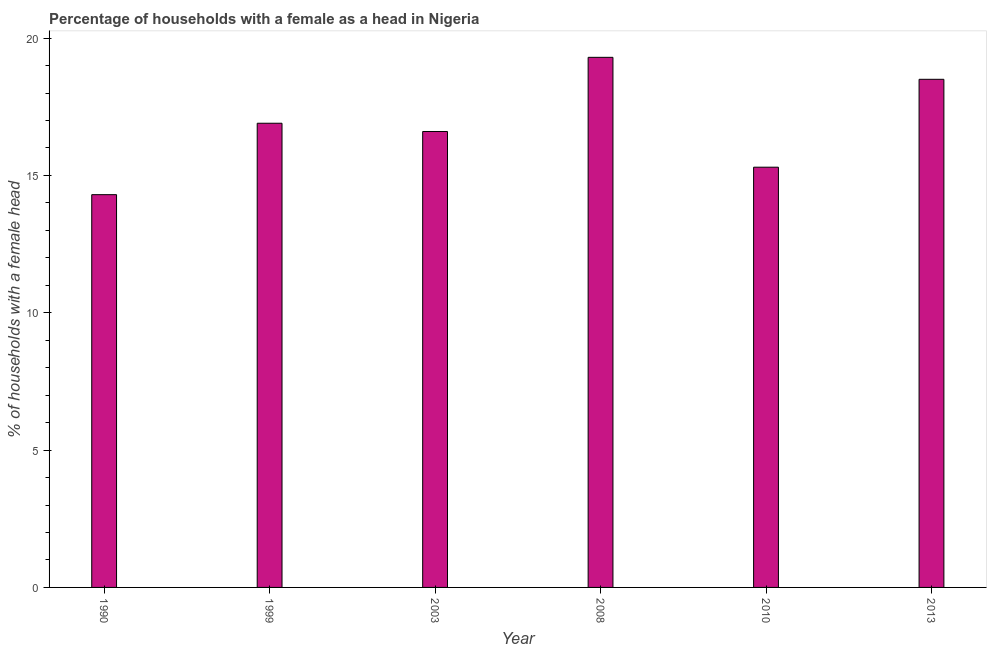Does the graph contain any zero values?
Make the answer very short. No. What is the title of the graph?
Your response must be concise. Percentage of households with a female as a head in Nigeria. What is the label or title of the Y-axis?
Make the answer very short. % of households with a female head. What is the number of female supervised households in 2008?
Your response must be concise. 19.3. Across all years, what is the maximum number of female supervised households?
Offer a very short reply. 19.3. In which year was the number of female supervised households maximum?
Your answer should be very brief. 2008. What is the sum of the number of female supervised households?
Provide a succinct answer. 100.9. What is the average number of female supervised households per year?
Your answer should be very brief. 16.82. What is the median number of female supervised households?
Provide a short and direct response. 16.75. Do a majority of the years between 1999 and 2013 (inclusive) have number of female supervised households greater than 16 %?
Provide a succinct answer. Yes. What is the ratio of the number of female supervised households in 2003 to that in 2010?
Ensure brevity in your answer.  1.08. Is the number of female supervised households in 2008 less than that in 2010?
Your response must be concise. No. What is the difference between the highest and the second highest number of female supervised households?
Offer a terse response. 0.8. Is the sum of the number of female supervised households in 1990 and 2013 greater than the maximum number of female supervised households across all years?
Your response must be concise. Yes. What is the difference between the highest and the lowest number of female supervised households?
Provide a short and direct response. 5. In how many years, is the number of female supervised households greater than the average number of female supervised households taken over all years?
Your answer should be compact. 3. How many bars are there?
Provide a short and direct response. 6. How many years are there in the graph?
Provide a short and direct response. 6. What is the % of households with a female head of 1999?
Offer a very short reply. 16.9. What is the % of households with a female head of 2008?
Provide a succinct answer. 19.3. What is the % of households with a female head of 2013?
Keep it short and to the point. 18.5. What is the difference between the % of households with a female head in 1990 and 2003?
Provide a succinct answer. -2.3. What is the difference between the % of households with a female head in 1999 and 2008?
Give a very brief answer. -2.4. What is the difference between the % of households with a female head in 1999 and 2010?
Ensure brevity in your answer.  1.6. What is the difference between the % of households with a female head in 2003 and 2008?
Your answer should be very brief. -2.7. What is the difference between the % of households with a female head in 2003 and 2010?
Provide a succinct answer. 1.3. What is the difference between the % of households with a female head in 2003 and 2013?
Make the answer very short. -1.9. What is the difference between the % of households with a female head in 2010 and 2013?
Provide a succinct answer. -3.2. What is the ratio of the % of households with a female head in 1990 to that in 1999?
Keep it short and to the point. 0.85. What is the ratio of the % of households with a female head in 1990 to that in 2003?
Make the answer very short. 0.86. What is the ratio of the % of households with a female head in 1990 to that in 2008?
Your answer should be compact. 0.74. What is the ratio of the % of households with a female head in 1990 to that in 2010?
Ensure brevity in your answer.  0.94. What is the ratio of the % of households with a female head in 1990 to that in 2013?
Provide a short and direct response. 0.77. What is the ratio of the % of households with a female head in 1999 to that in 2008?
Keep it short and to the point. 0.88. What is the ratio of the % of households with a female head in 1999 to that in 2010?
Make the answer very short. 1.1. What is the ratio of the % of households with a female head in 1999 to that in 2013?
Your answer should be very brief. 0.91. What is the ratio of the % of households with a female head in 2003 to that in 2008?
Keep it short and to the point. 0.86. What is the ratio of the % of households with a female head in 2003 to that in 2010?
Offer a terse response. 1.08. What is the ratio of the % of households with a female head in 2003 to that in 2013?
Provide a short and direct response. 0.9. What is the ratio of the % of households with a female head in 2008 to that in 2010?
Provide a short and direct response. 1.26. What is the ratio of the % of households with a female head in 2008 to that in 2013?
Give a very brief answer. 1.04. What is the ratio of the % of households with a female head in 2010 to that in 2013?
Provide a short and direct response. 0.83. 